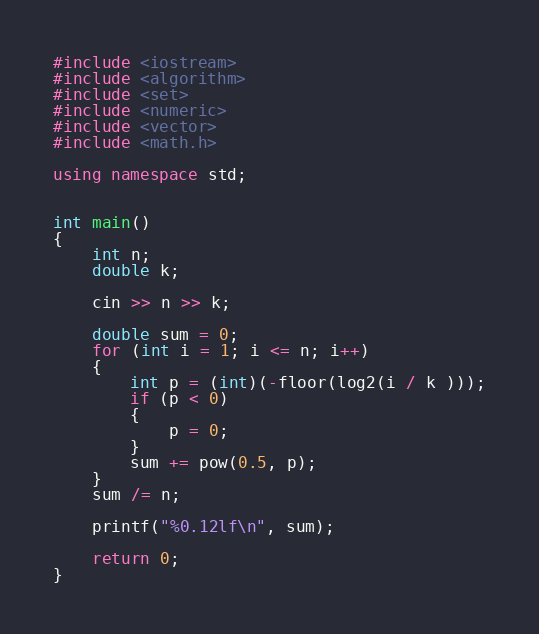<code> <loc_0><loc_0><loc_500><loc_500><_C++_>#include <iostream>
#include <algorithm>
#include <set>
#include <numeric>
#include <vector>
#include <math.h>

using namespace std;


int main()
{
	int n;
	double k;

	cin >> n >> k;

	double sum = 0;
	for (int i = 1; i <= n; i++)
	{
		int p = (int)(-floor(log2(i / k )));
		if (p < 0)
		{
			p = 0;
		}
		sum += pow(0.5, p);
	}
	sum /= n;

	printf("%0.12lf\n", sum);

	return 0;
}</code> 